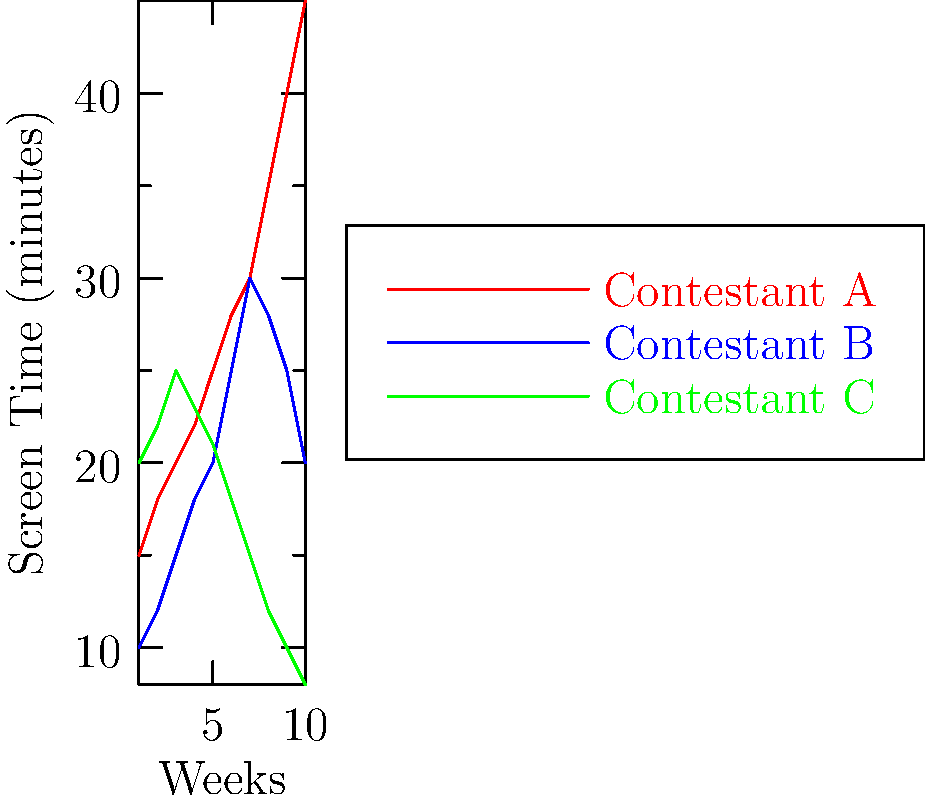Based on the line graph showing the screen time of three contestants over a 10-week season of The Bachelor, which contestant demonstrates the most consistent upward trend in screen time, and what might this suggest about their journey on the show? To answer this question, we need to analyze the trends for each contestant:

1. Contestant A (red line):
   - Starts at around 15 minutes in week 1
   - Shows a consistent upward trend throughout the season
   - Ends with the highest screen time of about 45 minutes in week 10

2. Contestant B (blue line):
   - Starts at about 10 minutes in week 1
   - Increases until week 7, reaching about 30 minutes
   - Decreases slightly in the last three weeks, ending at around 20 minutes

3. Contestant C (green line):
   - Starts with the highest screen time of about 20 minutes in week 1
   - Increases slightly until week 3, reaching about 25 minutes
   - Shows a consistent downward trend from week 3 onwards
   - Ends with the lowest screen time of about 8 minutes in week 10

Contestant A demonstrates the most consistent upward trend in screen time. This suggests:

1. Increasing importance in the show's narrative
2. Growing connection with the Bachelor
3. Potential to be a front-runner or eventual winner
4. More involvement in dramatic moments or key storylines

The consistent increase in screen time often correlates with a contestant's progression and significance in the show, making them a likely finalist or winner.
Answer: Contestant A; likely a front-runner or potential winner due to consistently increasing screen time. 